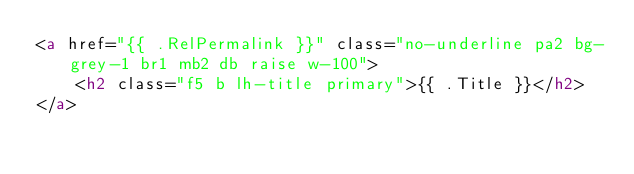Convert code to text. <code><loc_0><loc_0><loc_500><loc_500><_HTML_><a href="{{ .RelPermalink }}" class="no-underline pa2 bg-grey-1 br1 mb2 db raise w-100">
	<h2 class="f5 b lh-title primary">{{ .Title }}</h2>
</a>
</code> 